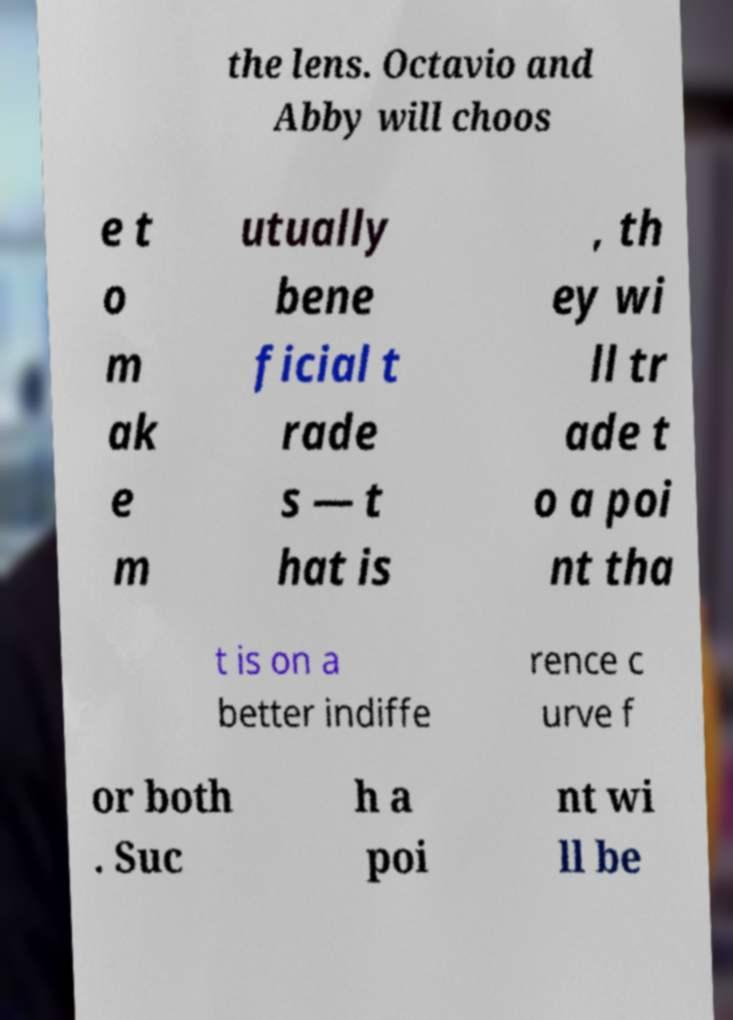There's text embedded in this image that I need extracted. Can you transcribe it verbatim? the lens. Octavio and Abby will choos e t o m ak e m utually bene ficial t rade s — t hat is , th ey wi ll tr ade t o a poi nt tha t is on a better indiffe rence c urve f or both . Suc h a poi nt wi ll be 